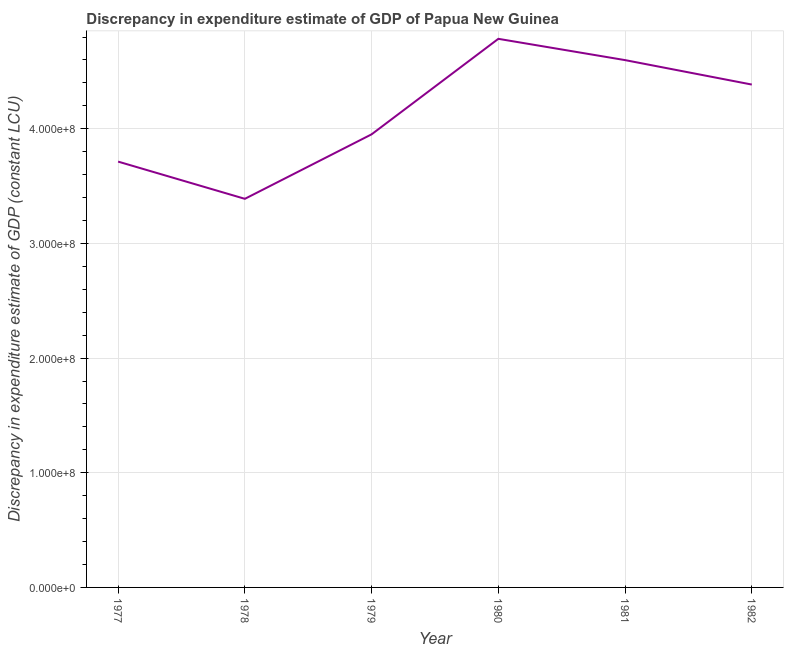What is the discrepancy in expenditure estimate of gdp in 1978?
Give a very brief answer. 3.39e+08. Across all years, what is the maximum discrepancy in expenditure estimate of gdp?
Your answer should be very brief. 4.78e+08. Across all years, what is the minimum discrepancy in expenditure estimate of gdp?
Offer a very short reply. 3.39e+08. In which year was the discrepancy in expenditure estimate of gdp minimum?
Your answer should be compact. 1978. What is the sum of the discrepancy in expenditure estimate of gdp?
Offer a terse response. 2.48e+09. What is the difference between the discrepancy in expenditure estimate of gdp in 1979 and 1981?
Provide a succinct answer. -6.47e+07. What is the average discrepancy in expenditure estimate of gdp per year?
Offer a very short reply. 4.14e+08. What is the median discrepancy in expenditure estimate of gdp?
Ensure brevity in your answer.  4.17e+08. In how many years, is the discrepancy in expenditure estimate of gdp greater than 260000000 LCU?
Provide a short and direct response. 6. What is the ratio of the discrepancy in expenditure estimate of gdp in 1977 to that in 1981?
Your response must be concise. 0.81. Is the difference between the discrepancy in expenditure estimate of gdp in 1977 and 1981 greater than the difference between any two years?
Your answer should be very brief. No. What is the difference between the highest and the second highest discrepancy in expenditure estimate of gdp?
Your response must be concise. 1.86e+07. What is the difference between the highest and the lowest discrepancy in expenditure estimate of gdp?
Your response must be concise. 1.40e+08. Does the discrepancy in expenditure estimate of gdp monotonically increase over the years?
Your answer should be very brief. No. How many lines are there?
Make the answer very short. 1. How many years are there in the graph?
Provide a succinct answer. 6. Does the graph contain grids?
Give a very brief answer. Yes. What is the title of the graph?
Provide a succinct answer. Discrepancy in expenditure estimate of GDP of Papua New Guinea. What is the label or title of the Y-axis?
Offer a terse response. Discrepancy in expenditure estimate of GDP (constant LCU). What is the Discrepancy in expenditure estimate of GDP (constant LCU) in 1977?
Your response must be concise. 3.71e+08. What is the Discrepancy in expenditure estimate of GDP (constant LCU) in 1978?
Provide a short and direct response. 3.39e+08. What is the Discrepancy in expenditure estimate of GDP (constant LCU) in 1979?
Your answer should be very brief. 3.95e+08. What is the Discrepancy in expenditure estimate of GDP (constant LCU) of 1980?
Offer a very short reply. 4.78e+08. What is the Discrepancy in expenditure estimate of GDP (constant LCU) of 1981?
Make the answer very short. 4.60e+08. What is the Discrepancy in expenditure estimate of GDP (constant LCU) in 1982?
Your answer should be very brief. 4.39e+08. What is the difference between the Discrepancy in expenditure estimate of GDP (constant LCU) in 1977 and 1978?
Keep it short and to the point. 3.25e+07. What is the difference between the Discrepancy in expenditure estimate of GDP (constant LCU) in 1977 and 1979?
Your answer should be compact. -2.38e+07. What is the difference between the Discrepancy in expenditure estimate of GDP (constant LCU) in 1977 and 1980?
Your answer should be compact. -1.07e+08. What is the difference between the Discrepancy in expenditure estimate of GDP (constant LCU) in 1977 and 1981?
Offer a very short reply. -8.85e+07. What is the difference between the Discrepancy in expenditure estimate of GDP (constant LCU) in 1977 and 1982?
Your answer should be very brief. -6.72e+07. What is the difference between the Discrepancy in expenditure estimate of GDP (constant LCU) in 1978 and 1979?
Make the answer very short. -5.62e+07. What is the difference between the Discrepancy in expenditure estimate of GDP (constant LCU) in 1978 and 1980?
Provide a short and direct response. -1.40e+08. What is the difference between the Discrepancy in expenditure estimate of GDP (constant LCU) in 1978 and 1981?
Your answer should be compact. -1.21e+08. What is the difference between the Discrepancy in expenditure estimate of GDP (constant LCU) in 1978 and 1982?
Your response must be concise. -9.96e+07. What is the difference between the Discrepancy in expenditure estimate of GDP (constant LCU) in 1979 and 1980?
Your answer should be compact. -8.33e+07. What is the difference between the Discrepancy in expenditure estimate of GDP (constant LCU) in 1979 and 1981?
Provide a short and direct response. -6.47e+07. What is the difference between the Discrepancy in expenditure estimate of GDP (constant LCU) in 1979 and 1982?
Make the answer very short. -4.34e+07. What is the difference between the Discrepancy in expenditure estimate of GDP (constant LCU) in 1980 and 1981?
Offer a very short reply. 1.86e+07. What is the difference between the Discrepancy in expenditure estimate of GDP (constant LCU) in 1980 and 1982?
Offer a very short reply. 3.99e+07. What is the difference between the Discrepancy in expenditure estimate of GDP (constant LCU) in 1981 and 1982?
Your answer should be very brief. 2.13e+07. What is the ratio of the Discrepancy in expenditure estimate of GDP (constant LCU) in 1977 to that in 1978?
Provide a succinct answer. 1.1. What is the ratio of the Discrepancy in expenditure estimate of GDP (constant LCU) in 1977 to that in 1980?
Ensure brevity in your answer.  0.78. What is the ratio of the Discrepancy in expenditure estimate of GDP (constant LCU) in 1977 to that in 1981?
Provide a short and direct response. 0.81. What is the ratio of the Discrepancy in expenditure estimate of GDP (constant LCU) in 1977 to that in 1982?
Ensure brevity in your answer.  0.85. What is the ratio of the Discrepancy in expenditure estimate of GDP (constant LCU) in 1978 to that in 1979?
Make the answer very short. 0.86. What is the ratio of the Discrepancy in expenditure estimate of GDP (constant LCU) in 1978 to that in 1980?
Keep it short and to the point. 0.71. What is the ratio of the Discrepancy in expenditure estimate of GDP (constant LCU) in 1978 to that in 1981?
Provide a short and direct response. 0.74. What is the ratio of the Discrepancy in expenditure estimate of GDP (constant LCU) in 1978 to that in 1982?
Your answer should be compact. 0.77. What is the ratio of the Discrepancy in expenditure estimate of GDP (constant LCU) in 1979 to that in 1980?
Keep it short and to the point. 0.83. What is the ratio of the Discrepancy in expenditure estimate of GDP (constant LCU) in 1979 to that in 1981?
Offer a terse response. 0.86. What is the ratio of the Discrepancy in expenditure estimate of GDP (constant LCU) in 1979 to that in 1982?
Your response must be concise. 0.9. What is the ratio of the Discrepancy in expenditure estimate of GDP (constant LCU) in 1980 to that in 1982?
Provide a short and direct response. 1.09. What is the ratio of the Discrepancy in expenditure estimate of GDP (constant LCU) in 1981 to that in 1982?
Your response must be concise. 1.05. 